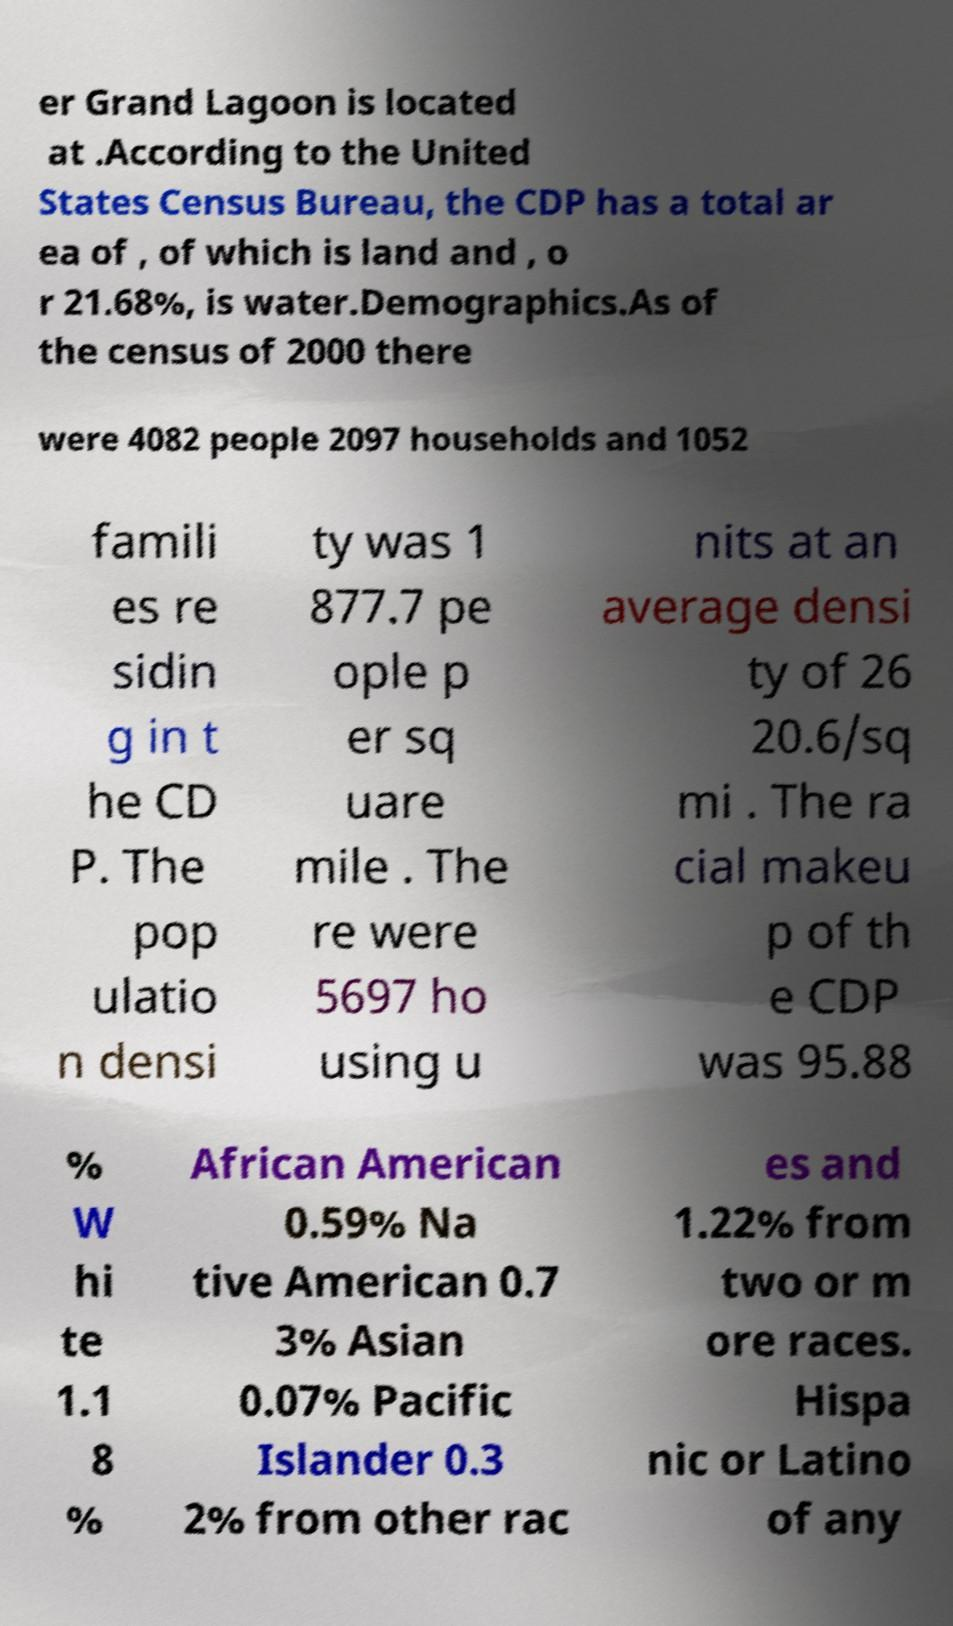Please read and relay the text visible in this image. What does it say? er Grand Lagoon is located at .According to the United States Census Bureau, the CDP has a total ar ea of , of which is land and , o r 21.68%, is water.Demographics.As of the census of 2000 there were 4082 people 2097 households and 1052 famili es re sidin g in t he CD P. The pop ulatio n densi ty was 1 877.7 pe ople p er sq uare mile . The re were 5697 ho using u nits at an average densi ty of 26 20.6/sq mi . The ra cial makeu p of th e CDP was 95.88 % W hi te 1.1 8 % African American 0.59% Na tive American 0.7 3% Asian 0.07% Pacific Islander 0.3 2% from other rac es and 1.22% from two or m ore races. Hispa nic or Latino of any 